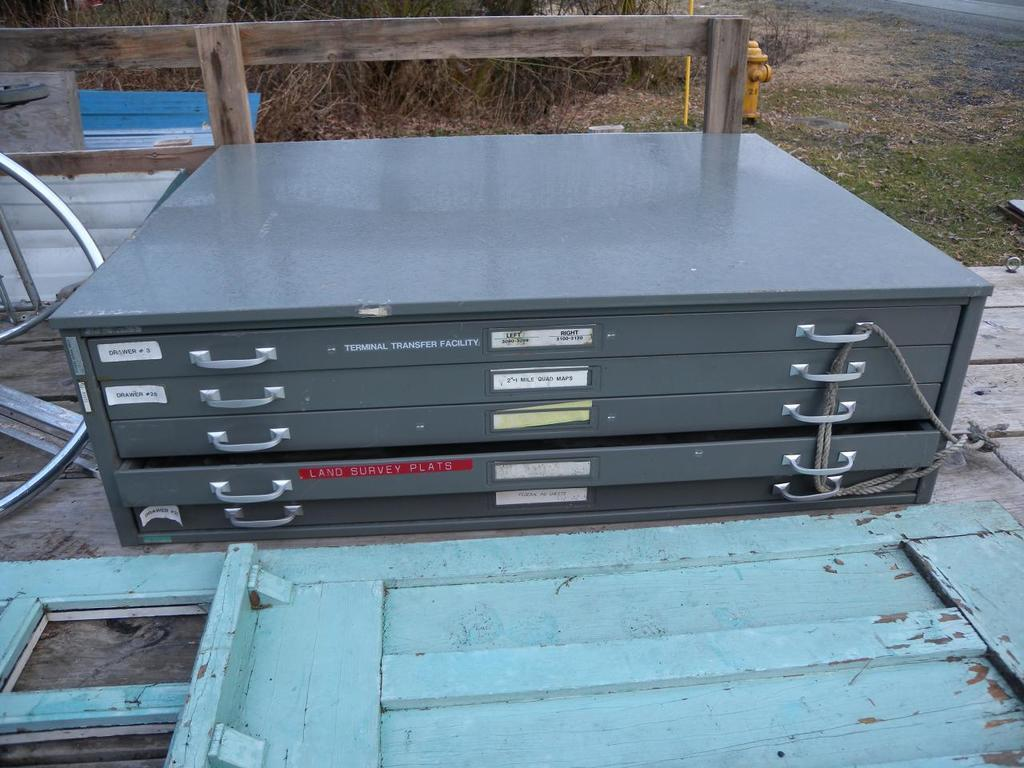Provide a one-sentence caption for the provided image. Flat container outdoors with a sticker that says "Drawer 3" near the top left. 